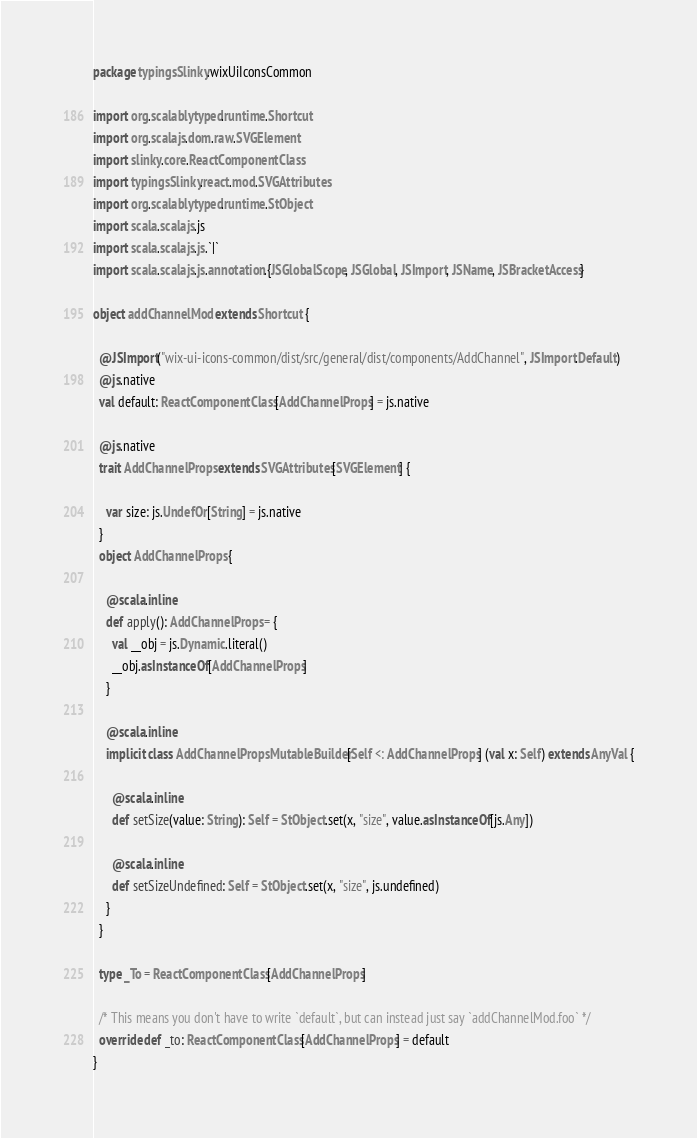Convert code to text. <code><loc_0><loc_0><loc_500><loc_500><_Scala_>package typingsSlinky.wixUiIconsCommon

import org.scalablytyped.runtime.Shortcut
import org.scalajs.dom.raw.SVGElement
import slinky.core.ReactComponentClass
import typingsSlinky.react.mod.SVGAttributes
import org.scalablytyped.runtime.StObject
import scala.scalajs.js
import scala.scalajs.js.`|`
import scala.scalajs.js.annotation.{JSGlobalScope, JSGlobal, JSImport, JSName, JSBracketAccess}

object addChannelMod extends Shortcut {
  
  @JSImport("wix-ui-icons-common/dist/src/general/dist/components/AddChannel", JSImport.Default)
  @js.native
  val default: ReactComponentClass[AddChannelProps] = js.native
  
  @js.native
  trait AddChannelProps extends SVGAttributes[SVGElement] {
    
    var size: js.UndefOr[String] = js.native
  }
  object AddChannelProps {
    
    @scala.inline
    def apply(): AddChannelProps = {
      val __obj = js.Dynamic.literal()
      __obj.asInstanceOf[AddChannelProps]
    }
    
    @scala.inline
    implicit class AddChannelPropsMutableBuilder[Self <: AddChannelProps] (val x: Self) extends AnyVal {
      
      @scala.inline
      def setSize(value: String): Self = StObject.set(x, "size", value.asInstanceOf[js.Any])
      
      @scala.inline
      def setSizeUndefined: Self = StObject.set(x, "size", js.undefined)
    }
  }
  
  type _To = ReactComponentClass[AddChannelProps]
  
  /* This means you don't have to write `default`, but can instead just say `addChannelMod.foo` */
  override def _to: ReactComponentClass[AddChannelProps] = default
}
</code> 